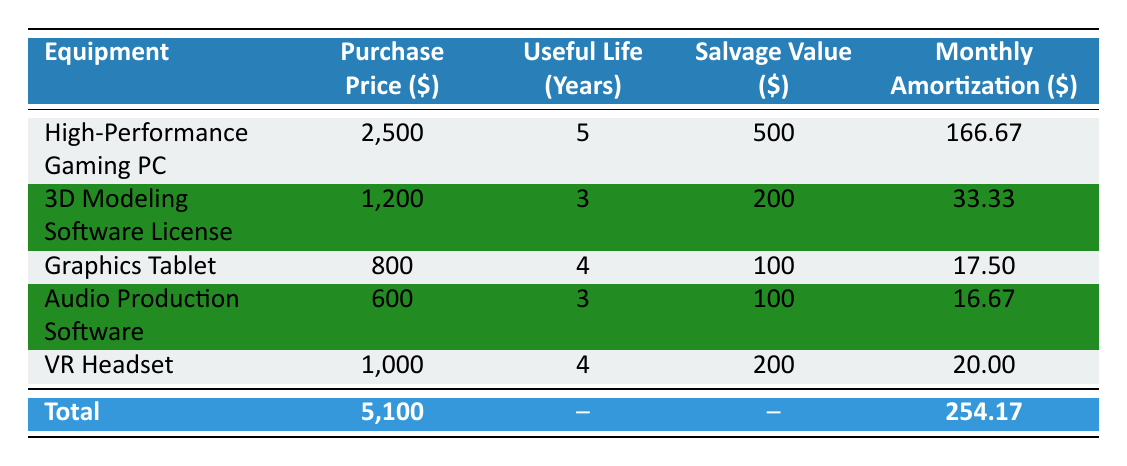What is the purchase price of the High-Performance Gaming PC? The purchase price for the High-Performance Gaming PC is listed in the table under the "Purchase Price" column next to the item's name. It shows \$2500.
Answer: 2500 What is the monthly amortization amount for the 3D Modeling Software License? The monthly amortization amount for the 3D Modeling Software License can be found in the "Monthly Amortization" column, where it indicates \$33.33 for this item.
Answer: 33.33 What is the total cost of all equipment purchased? To find the total cost, refer to the "Total" row at the bottom of the table where it clearly shows the total cost is \$5100.
Answer: 5100 Which equipment has the highest monthly amortization? By comparing the "Monthly Amortization" values in each row, the High-Performance Gaming PC has the highest monthly amortization at \$166.67.
Answer: High-Performance Gaming PC Is the salvage value of the Graphics Tablet higher than that of the Audio Production Software? The salvage value of the Graphics Tablet is \$100, and for the Audio Production Software, it is also \$100. Comparing both shows they are equal, so the answer is No.
Answer: No What is the average monthly amortization of all equipment? First, sum the monthly amortizations: 166.67 + 33.33 + 17.50 + 16.67 + 20.00 = 254.17. Then, divide by the number of equipment items (5): 254.17 / 5 = 50.83.
Answer: 50.83 What is the total salvage value of all the equipment? To find the total salvage value, add the salvage values from the "Salvage Value" column: 500 + 200 + 100 + 100 + 200 = 1100.
Answer: 1100 How many pieces of equipment have a useful life of more than 4 years? Examining the "Useful Life (Years)" column, the High-Performance Gaming PC (5 years) is the only equipment item listed with a useful life greater than 4 years.
Answer: 1 Is there any equipment with a purchase price lower than \$1000? Yes, the Graphics Tablet (\$800) and the Audio Production Software (\$600) both have purchase prices lower than \$1000, therefore the answer is Yes.
Answer: Yes 